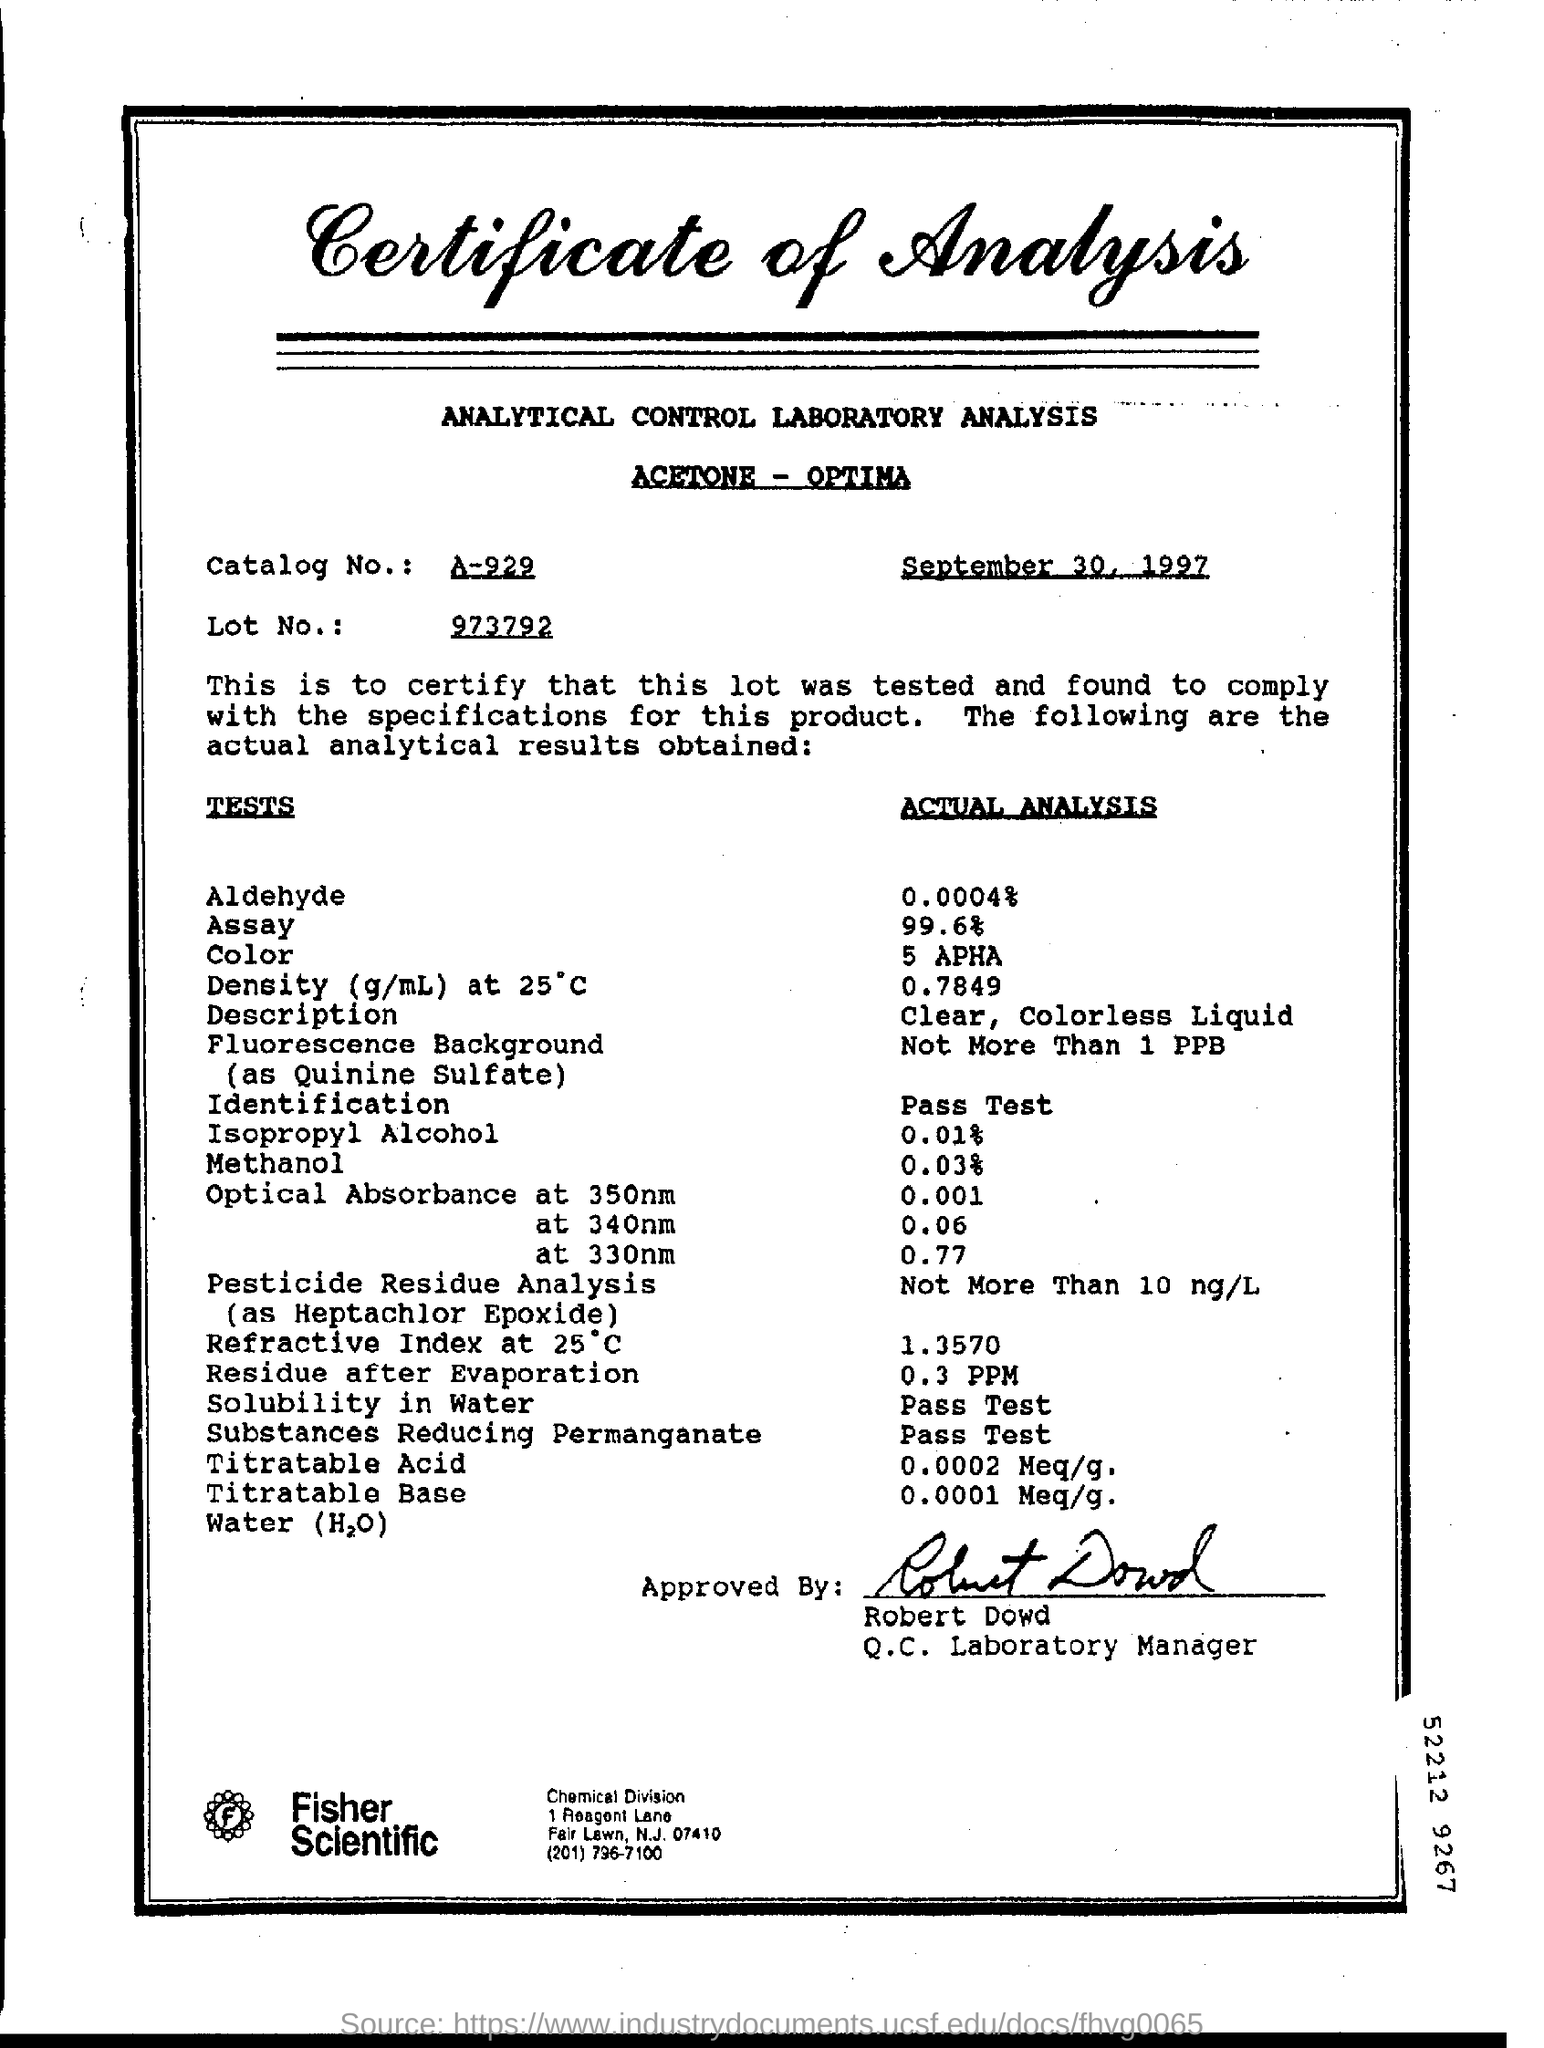Draw attention to some important aspects in this diagram. The catalog number is A-929. The date mentioned at the top of the document is September 30, 1997. The actual analysis of color is 5 APHA. The Q.C. Laboratory Manager is Robert Dowd. 